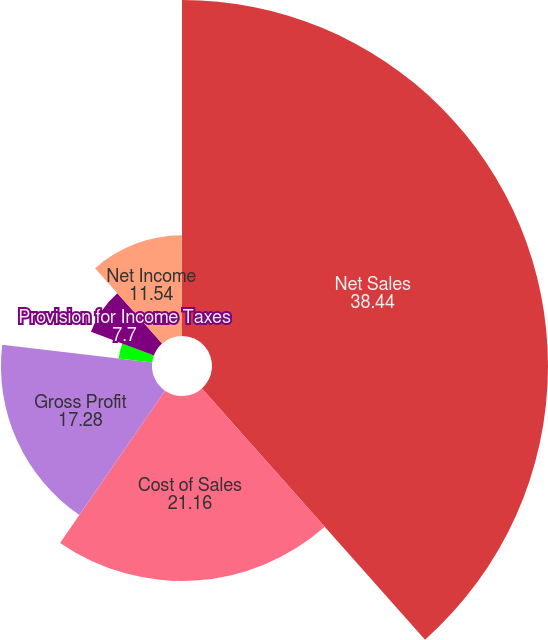Convert chart. <chart><loc_0><loc_0><loc_500><loc_500><pie_chart><fcel>Net Sales<fcel>Cost of Sales<fcel>Gross Profit<fcel>Interest Expense Net<fcel>Provision for Income Taxes<fcel>Net Income<fcel>Net Income Per Share-Diluted<nl><fcel>38.44%<fcel>21.16%<fcel>17.28%<fcel>3.86%<fcel>7.7%<fcel>11.54%<fcel>0.02%<nl></chart> 